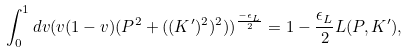Convert formula to latex. <formula><loc_0><loc_0><loc_500><loc_500>\int _ { 0 } ^ { 1 } d v ( v ( 1 - v ) ( P ^ { 2 } + ( ( K ^ { \prime } ) ^ { 2 } ) ^ { 2 } ) ) ^ { \frac { - \epsilon _ { L } } { 2 } } = 1 - \frac { \epsilon _ { L } } { 2 } L ( P , K ^ { \prime } ) ,</formula> 